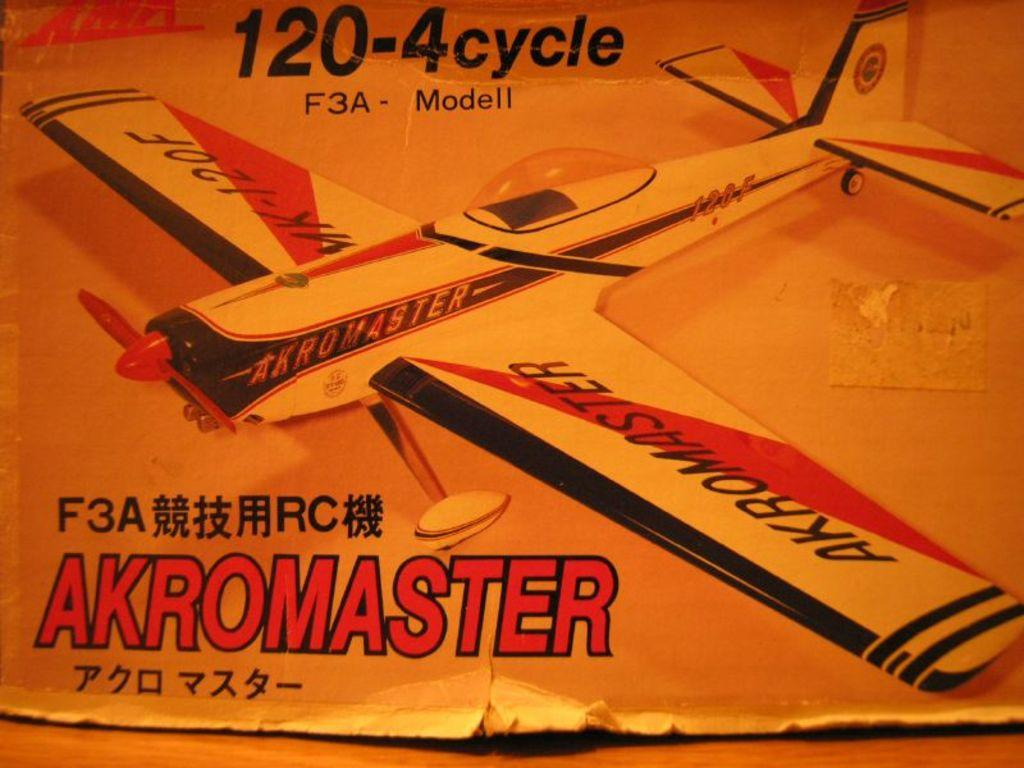<image>
Share a concise interpretation of the image provided. a box is showing a model with 120-4 cycle on it 